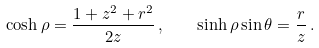Convert formula to latex. <formula><loc_0><loc_0><loc_500><loc_500>\cosh \rho = \frac { 1 + z ^ { 2 } + r ^ { 2 } } { 2 z } \, , \quad \sinh \rho \sin \theta = \frac { r } { z } \, .</formula> 